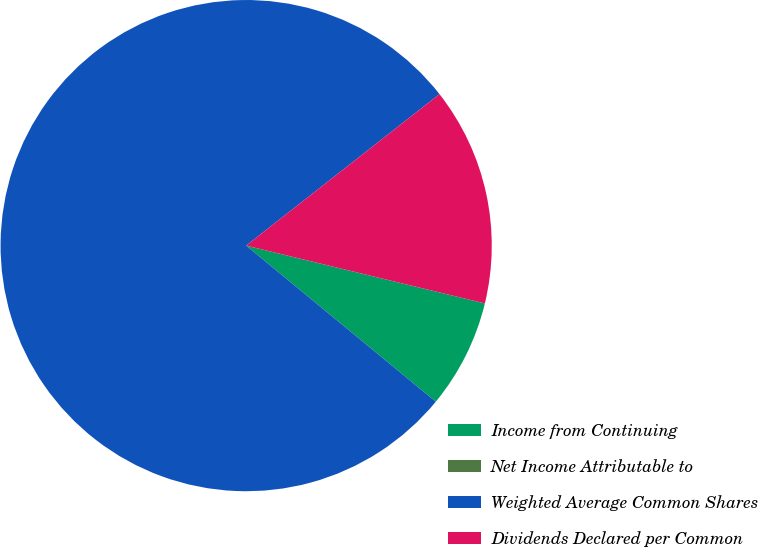<chart> <loc_0><loc_0><loc_500><loc_500><pie_chart><fcel>Income from Continuing<fcel>Net Income Attributable to<fcel>Weighted Average Common Shares<fcel>Dividends Declared per Common<nl><fcel>7.18%<fcel>0.0%<fcel>78.46%<fcel>14.36%<nl></chart> 